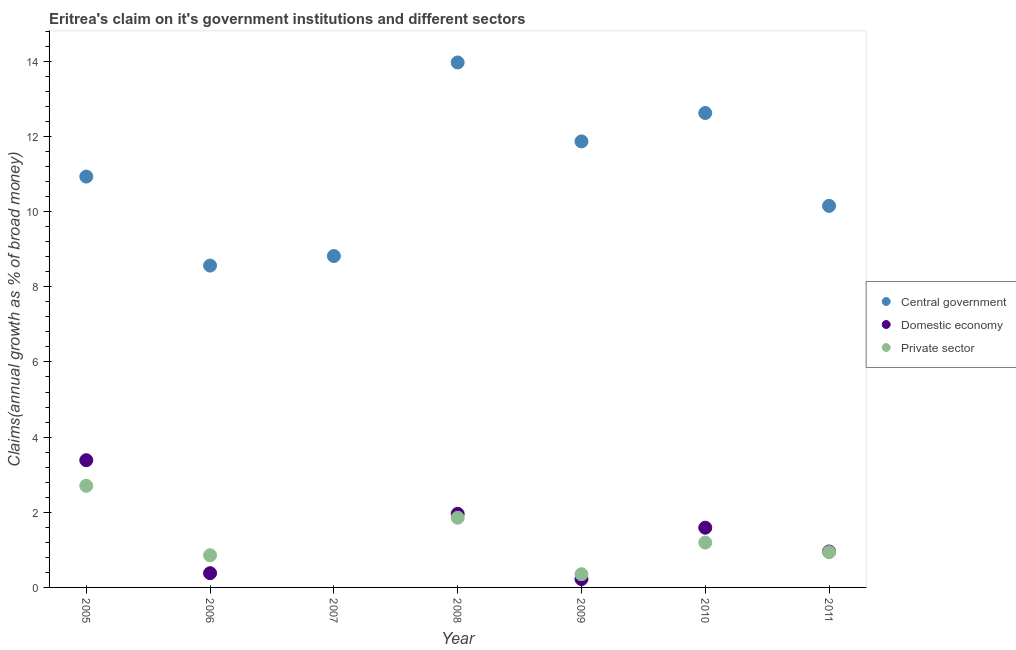What is the percentage of claim on the central government in 2007?
Keep it short and to the point. 8.82. Across all years, what is the maximum percentage of claim on the central government?
Your response must be concise. 13.97. Across all years, what is the minimum percentage of claim on the private sector?
Ensure brevity in your answer.  0. What is the total percentage of claim on the central government in the graph?
Ensure brevity in your answer.  76.93. What is the difference between the percentage of claim on the private sector in 2009 and that in 2011?
Ensure brevity in your answer.  -0.59. What is the difference between the percentage of claim on the private sector in 2008 and the percentage of claim on the central government in 2009?
Offer a terse response. -10.01. What is the average percentage of claim on the central government per year?
Give a very brief answer. 10.99. In the year 2006, what is the difference between the percentage of claim on the private sector and percentage of claim on the domestic economy?
Offer a terse response. 0.48. In how many years, is the percentage of claim on the domestic economy greater than 8 %?
Ensure brevity in your answer.  0. What is the ratio of the percentage of claim on the private sector in 2008 to that in 2011?
Ensure brevity in your answer.  1.98. Is the percentage of claim on the domestic economy in 2008 less than that in 2010?
Make the answer very short. No. Is the difference between the percentage of claim on the central government in 2006 and 2010 greater than the difference between the percentage of claim on the private sector in 2006 and 2010?
Keep it short and to the point. No. What is the difference between the highest and the second highest percentage of claim on the private sector?
Provide a succinct answer. 0.85. What is the difference between the highest and the lowest percentage of claim on the domestic economy?
Your response must be concise. 3.39. In how many years, is the percentage of claim on the domestic economy greater than the average percentage of claim on the domestic economy taken over all years?
Provide a short and direct response. 3. Is the sum of the percentage of claim on the domestic economy in 2008 and 2011 greater than the maximum percentage of claim on the central government across all years?
Provide a short and direct response. No. Does the percentage of claim on the central government monotonically increase over the years?
Your response must be concise. No. Is the percentage of claim on the private sector strictly greater than the percentage of claim on the central government over the years?
Make the answer very short. No. How many dotlines are there?
Ensure brevity in your answer.  3. Are the values on the major ticks of Y-axis written in scientific E-notation?
Your answer should be compact. No. Does the graph contain any zero values?
Your answer should be compact. Yes. Where does the legend appear in the graph?
Ensure brevity in your answer.  Center right. How are the legend labels stacked?
Provide a short and direct response. Vertical. What is the title of the graph?
Your answer should be very brief. Eritrea's claim on it's government institutions and different sectors. What is the label or title of the Y-axis?
Your response must be concise. Claims(annual growth as % of broad money). What is the Claims(annual growth as % of broad money) of Central government in 2005?
Your answer should be compact. 10.93. What is the Claims(annual growth as % of broad money) in Domestic economy in 2005?
Your answer should be compact. 3.39. What is the Claims(annual growth as % of broad money) of Private sector in 2005?
Your answer should be very brief. 2.7. What is the Claims(annual growth as % of broad money) of Central government in 2006?
Your answer should be compact. 8.56. What is the Claims(annual growth as % of broad money) in Domestic economy in 2006?
Your answer should be compact. 0.38. What is the Claims(annual growth as % of broad money) in Private sector in 2006?
Make the answer very short. 0.86. What is the Claims(annual growth as % of broad money) in Central government in 2007?
Provide a short and direct response. 8.82. What is the Claims(annual growth as % of broad money) of Central government in 2008?
Your response must be concise. 13.97. What is the Claims(annual growth as % of broad money) in Domestic economy in 2008?
Ensure brevity in your answer.  1.96. What is the Claims(annual growth as % of broad money) in Private sector in 2008?
Your answer should be compact. 1.85. What is the Claims(annual growth as % of broad money) of Central government in 2009?
Make the answer very short. 11.87. What is the Claims(annual growth as % of broad money) in Domestic economy in 2009?
Provide a succinct answer. 0.22. What is the Claims(annual growth as % of broad money) in Private sector in 2009?
Ensure brevity in your answer.  0.35. What is the Claims(annual growth as % of broad money) in Central government in 2010?
Keep it short and to the point. 12.62. What is the Claims(annual growth as % of broad money) in Domestic economy in 2010?
Make the answer very short. 1.59. What is the Claims(annual growth as % of broad money) of Private sector in 2010?
Provide a succinct answer. 1.19. What is the Claims(annual growth as % of broad money) of Central government in 2011?
Provide a succinct answer. 10.15. What is the Claims(annual growth as % of broad money) in Domestic economy in 2011?
Give a very brief answer. 0.96. What is the Claims(annual growth as % of broad money) in Private sector in 2011?
Provide a short and direct response. 0.94. Across all years, what is the maximum Claims(annual growth as % of broad money) in Central government?
Make the answer very short. 13.97. Across all years, what is the maximum Claims(annual growth as % of broad money) of Domestic economy?
Give a very brief answer. 3.39. Across all years, what is the maximum Claims(annual growth as % of broad money) of Private sector?
Offer a terse response. 2.7. Across all years, what is the minimum Claims(annual growth as % of broad money) in Central government?
Your response must be concise. 8.56. Across all years, what is the minimum Claims(annual growth as % of broad money) of Domestic economy?
Ensure brevity in your answer.  0. What is the total Claims(annual growth as % of broad money) of Central government in the graph?
Make the answer very short. 76.93. What is the total Claims(annual growth as % of broad money) in Domestic economy in the graph?
Provide a short and direct response. 8.49. What is the total Claims(annual growth as % of broad money) in Private sector in the graph?
Your answer should be compact. 7.9. What is the difference between the Claims(annual growth as % of broad money) of Central government in 2005 and that in 2006?
Give a very brief answer. 2.37. What is the difference between the Claims(annual growth as % of broad money) in Domestic economy in 2005 and that in 2006?
Give a very brief answer. 3.01. What is the difference between the Claims(annual growth as % of broad money) of Private sector in 2005 and that in 2006?
Offer a very short reply. 1.85. What is the difference between the Claims(annual growth as % of broad money) of Central government in 2005 and that in 2007?
Your answer should be compact. 2.11. What is the difference between the Claims(annual growth as % of broad money) of Central government in 2005 and that in 2008?
Your answer should be very brief. -3.04. What is the difference between the Claims(annual growth as % of broad money) in Domestic economy in 2005 and that in 2008?
Your answer should be compact. 1.43. What is the difference between the Claims(annual growth as % of broad money) in Private sector in 2005 and that in 2008?
Your response must be concise. 0.85. What is the difference between the Claims(annual growth as % of broad money) in Central government in 2005 and that in 2009?
Your answer should be compact. -0.94. What is the difference between the Claims(annual growth as % of broad money) of Domestic economy in 2005 and that in 2009?
Offer a terse response. 3.16. What is the difference between the Claims(annual growth as % of broad money) of Private sector in 2005 and that in 2009?
Make the answer very short. 2.35. What is the difference between the Claims(annual growth as % of broad money) of Central government in 2005 and that in 2010?
Your response must be concise. -1.69. What is the difference between the Claims(annual growth as % of broad money) in Domestic economy in 2005 and that in 2010?
Your answer should be compact. 1.8. What is the difference between the Claims(annual growth as % of broad money) of Private sector in 2005 and that in 2010?
Make the answer very short. 1.51. What is the difference between the Claims(annual growth as % of broad money) of Central government in 2005 and that in 2011?
Give a very brief answer. 0.78. What is the difference between the Claims(annual growth as % of broad money) in Domestic economy in 2005 and that in 2011?
Offer a terse response. 2.43. What is the difference between the Claims(annual growth as % of broad money) of Private sector in 2005 and that in 2011?
Provide a short and direct response. 1.77. What is the difference between the Claims(annual growth as % of broad money) in Central government in 2006 and that in 2007?
Your answer should be compact. -0.25. What is the difference between the Claims(annual growth as % of broad money) of Central government in 2006 and that in 2008?
Your answer should be compact. -5.41. What is the difference between the Claims(annual growth as % of broad money) of Domestic economy in 2006 and that in 2008?
Your answer should be very brief. -1.58. What is the difference between the Claims(annual growth as % of broad money) of Private sector in 2006 and that in 2008?
Provide a succinct answer. -1. What is the difference between the Claims(annual growth as % of broad money) in Central government in 2006 and that in 2009?
Provide a short and direct response. -3.3. What is the difference between the Claims(annual growth as % of broad money) in Domestic economy in 2006 and that in 2009?
Give a very brief answer. 0.16. What is the difference between the Claims(annual growth as % of broad money) of Private sector in 2006 and that in 2009?
Your response must be concise. 0.5. What is the difference between the Claims(annual growth as % of broad money) of Central government in 2006 and that in 2010?
Provide a succinct answer. -4.06. What is the difference between the Claims(annual growth as % of broad money) in Domestic economy in 2006 and that in 2010?
Your response must be concise. -1.21. What is the difference between the Claims(annual growth as % of broad money) in Private sector in 2006 and that in 2010?
Offer a very short reply. -0.34. What is the difference between the Claims(annual growth as % of broad money) in Central government in 2006 and that in 2011?
Make the answer very short. -1.59. What is the difference between the Claims(annual growth as % of broad money) in Domestic economy in 2006 and that in 2011?
Your answer should be compact. -0.58. What is the difference between the Claims(annual growth as % of broad money) of Private sector in 2006 and that in 2011?
Give a very brief answer. -0.08. What is the difference between the Claims(annual growth as % of broad money) of Central government in 2007 and that in 2008?
Your response must be concise. -5.15. What is the difference between the Claims(annual growth as % of broad money) in Central government in 2007 and that in 2009?
Provide a succinct answer. -3.05. What is the difference between the Claims(annual growth as % of broad money) in Central government in 2007 and that in 2010?
Make the answer very short. -3.81. What is the difference between the Claims(annual growth as % of broad money) in Central government in 2007 and that in 2011?
Give a very brief answer. -1.33. What is the difference between the Claims(annual growth as % of broad money) of Central government in 2008 and that in 2009?
Your answer should be very brief. 2.1. What is the difference between the Claims(annual growth as % of broad money) in Domestic economy in 2008 and that in 2009?
Your answer should be very brief. 1.74. What is the difference between the Claims(annual growth as % of broad money) of Private sector in 2008 and that in 2009?
Give a very brief answer. 1.5. What is the difference between the Claims(annual growth as % of broad money) of Central government in 2008 and that in 2010?
Give a very brief answer. 1.35. What is the difference between the Claims(annual growth as % of broad money) of Domestic economy in 2008 and that in 2010?
Make the answer very short. 0.37. What is the difference between the Claims(annual growth as % of broad money) of Private sector in 2008 and that in 2010?
Make the answer very short. 0.66. What is the difference between the Claims(annual growth as % of broad money) of Central government in 2008 and that in 2011?
Your answer should be very brief. 3.82. What is the difference between the Claims(annual growth as % of broad money) of Domestic economy in 2008 and that in 2011?
Ensure brevity in your answer.  1. What is the difference between the Claims(annual growth as % of broad money) in Private sector in 2008 and that in 2011?
Offer a very short reply. 0.92. What is the difference between the Claims(annual growth as % of broad money) of Central government in 2009 and that in 2010?
Your answer should be very brief. -0.76. What is the difference between the Claims(annual growth as % of broad money) of Domestic economy in 2009 and that in 2010?
Offer a very short reply. -1.37. What is the difference between the Claims(annual growth as % of broad money) of Private sector in 2009 and that in 2010?
Give a very brief answer. -0.84. What is the difference between the Claims(annual growth as % of broad money) in Central government in 2009 and that in 2011?
Keep it short and to the point. 1.72. What is the difference between the Claims(annual growth as % of broad money) in Domestic economy in 2009 and that in 2011?
Ensure brevity in your answer.  -0.73. What is the difference between the Claims(annual growth as % of broad money) in Private sector in 2009 and that in 2011?
Offer a very short reply. -0.59. What is the difference between the Claims(annual growth as % of broad money) in Central government in 2010 and that in 2011?
Your answer should be very brief. 2.47. What is the difference between the Claims(annual growth as % of broad money) of Domestic economy in 2010 and that in 2011?
Offer a terse response. 0.63. What is the difference between the Claims(annual growth as % of broad money) of Private sector in 2010 and that in 2011?
Keep it short and to the point. 0.26. What is the difference between the Claims(annual growth as % of broad money) in Central government in 2005 and the Claims(annual growth as % of broad money) in Domestic economy in 2006?
Offer a very short reply. 10.55. What is the difference between the Claims(annual growth as % of broad money) in Central government in 2005 and the Claims(annual growth as % of broad money) in Private sector in 2006?
Your response must be concise. 10.08. What is the difference between the Claims(annual growth as % of broad money) in Domestic economy in 2005 and the Claims(annual growth as % of broad money) in Private sector in 2006?
Keep it short and to the point. 2.53. What is the difference between the Claims(annual growth as % of broad money) of Central government in 2005 and the Claims(annual growth as % of broad money) of Domestic economy in 2008?
Provide a short and direct response. 8.97. What is the difference between the Claims(annual growth as % of broad money) in Central government in 2005 and the Claims(annual growth as % of broad money) in Private sector in 2008?
Make the answer very short. 9.08. What is the difference between the Claims(annual growth as % of broad money) of Domestic economy in 2005 and the Claims(annual growth as % of broad money) of Private sector in 2008?
Your answer should be very brief. 1.53. What is the difference between the Claims(annual growth as % of broad money) in Central government in 2005 and the Claims(annual growth as % of broad money) in Domestic economy in 2009?
Keep it short and to the point. 10.71. What is the difference between the Claims(annual growth as % of broad money) in Central government in 2005 and the Claims(annual growth as % of broad money) in Private sector in 2009?
Provide a succinct answer. 10.58. What is the difference between the Claims(annual growth as % of broad money) of Domestic economy in 2005 and the Claims(annual growth as % of broad money) of Private sector in 2009?
Provide a short and direct response. 3.03. What is the difference between the Claims(annual growth as % of broad money) in Central government in 2005 and the Claims(annual growth as % of broad money) in Domestic economy in 2010?
Make the answer very short. 9.34. What is the difference between the Claims(annual growth as % of broad money) in Central government in 2005 and the Claims(annual growth as % of broad money) in Private sector in 2010?
Give a very brief answer. 9.74. What is the difference between the Claims(annual growth as % of broad money) of Domestic economy in 2005 and the Claims(annual growth as % of broad money) of Private sector in 2010?
Offer a very short reply. 2.19. What is the difference between the Claims(annual growth as % of broad money) of Central government in 2005 and the Claims(annual growth as % of broad money) of Domestic economy in 2011?
Give a very brief answer. 9.98. What is the difference between the Claims(annual growth as % of broad money) of Central government in 2005 and the Claims(annual growth as % of broad money) of Private sector in 2011?
Offer a very short reply. 10. What is the difference between the Claims(annual growth as % of broad money) of Domestic economy in 2005 and the Claims(annual growth as % of broad money) of Private sector in 2011?
Ensure brevity in your answer.  2.45. What is the difference between the Claims(annual growth as % of broad money) of Central government in 2006 and the Claims(annual growth as % of broad money) of Domestic economy in 2008?
Keep it short and to the point. 6.61. What is the difference between the Claims(annual growth as % of broad money) in Central government in 2006 and the Claims(annual growth as % of broad money) in Private sector in 2008?
Offer a very short reply. 6.71. What is the difference between the Claims(annual growth as % of broad money) of Domestic economy in 2006 and the Claims(annual growth as % of broad money) of Private sector in 2008?
Make the answer very short. -1.47. What is the difference between the Claims(annual growth as % of broad money) in Central government in 2006 and the Claims(annual growth as % of broad money) in Domestic economy in 2009?
Your response must be concise. 8.34. What is the difference between the Claims(annual growth as % of broad money) in Central government in 2006 and the Claims(annual growth as % of broad money) in Private sector in 2009?
Give a very brief answer. 8.21. What is the difference between the Claims(annual growth as % of broad money) in Domestic economy in 2006 and the Claims(annual growth as % of broad money) in Private sector in 2009?
Make the answer very short. 0.03. What is the difference between the Claims(annual growth as % of broad money) of Central government in 2006 and the Claims(annual growth as % of broad money) of Domestic economy in 2010?
Your answer should be very brief. 6.98. What is the difference between the Claims(annual growth as % of broad money) in Central government in 2006 and the Claims(annual growth as % of broad money) in Private sector in 2010?
Keep it short and to the point. 7.37. What is the difference between the Claims(annual growth as % of broad money) in Domestic economy in 2006 and the Claims(annual growth as % of broad money) in Private sector in 2010?
Offer a very short reply. -0.81. What is the difference between the Claims(annual growth as % of broad money) of Central government in 2006 and the Claims(annual growth as % of broad money) of Domestic economy in 2011?
Offer a terse response. 7.61. What is the difference between the Claims(annual growth as % of broad money) in Central government in 2006 and the Claims(annual growth as % of broad money) in Private sector in 2011?
Keep it short and to the point. 7.63. What is the difference between the Claims(annual growth as % of broad money) of Domestic economy in 2006 and the Claims(annual growth as % of broad money) of Private sector in 2011?
Ensure brevity in your answer.  -0.56. What is the difference between the Claims(annual growth as % of broad money) in Central government in 2007 and the Claims(annual growth as % of broad money) in Domestic economy in 2008?
Provide a succinct answer. 6.86. What is the difference between the Claims(annual growth as % of broad money) in Central government in 2007 and the Claims(annual growth as % of broad money) in Private sector in 2008?
Your answer should be very brief. 6.97. What is the difference between the Claims(annual growth as % of broad money) in Central government in 2007 and the Claims(annual growth as % of broad money) in Domestic economy in 2009?
Give a very brief answer. 8.6. What is the difference between the Claims(annual growth as % of broad money) of Central government in 2007 and the Claims(annual growth as % of broad money) of Private sector in 2009?
Your answer should be very brief. 8.47. What is the difference between the Claims(annual growth as % of broad money) in Central government in 2007 and the Claims(annual growth as % of broad money) in Domestic economy in 2010?
Offer a very short reply. 7.23. What is the difference between the Claims(annual growth as % of broad money) in Central government in 2007 and the Claims(annual growth as % of broad money) in Private sector in 2010?
Your response must be concise. 7.63. What is the difference between the Claims(annual growth as % of broad money) in Central government in 2007 and the Claims(annual growth as % of broad money) in Domestic economy in 2011?
Ensure brevity in your answer.  7.86. What is the difference between the Claims(annual growth as % of broad money) of Central government in 2007 and the Claims(annual growth as % of broad money) of Private sector in 2011?
Your response must be concise. 7.88. What is the difference between the Claims(annual growth as % of broad money) of Central government in 2008 and the Claims(annual growth as % of broad money) of Domestic economy in 2009?
Make the answer very short. 13.75. What is the difference between the Claims(annual growth as % of broad money) in Central government in 2008 and the Claims(annual growth as % of broad money) in Private sector in 2009?
Ensure brevity in your answer.  13.62. What is the difference between the Claims(annual growth as % of broad money) of Domestic economy in 2008 and the Claims(annual growth as % of broad money) of Private sector in 2009?
Your answer should be compact. 1.61. What is the difference between the Claims(annual growth as % of broad money) in Central government in 2008 and the Claims(annual growth as % of broad money) in Domestic economy in 2010?
Keep it short and to the point. 12.38. What is the difference between the Claims(annual growth as % of broad money) of Central government in 2008 and the Claims(annual growth as % of broad money) of Private sector in 2010?
Your answer should be very brief. 12.78. What is the difference between the Claims(annual growth as % of broad money) of Domestic economy in 2008 and the Claims(annual growth as % of broad money) of Private sector in 2010?
Offer a terse response. 0.77. What is the difference between the Claims(annual growth as % of broad money) in Central government in 2008 and the Claims(annual growth as % of broad money) in Domestic economy in 2011?
Your response must be concise. 13.01. What is the difference between the Claims(annual growth as % of broad money) of Central government in 2008 and the Claims(annual growth as % of broad money) of Private sector in 2011?
Make the answer very short. 13.03. What is the difference between the Claims(annual growth as % of broad money) of Domestic economy in 2008 and the Claims(annual growth as % of broad money) of Private sector in 2011?
Keep it short and to the point. 1.02. What is the difference between the Claims(annual growth as % of broad money) in Central government in 2009 and the Claims(annual growth as % of broad money) in Domestic economy in 2010?
Keep it short and to the point. 10.28. What is the difference between the Claims(annual growth as % of broad money) in Central government in 2009 and the Claims(annual growth as % of broad money) in Private sector in 2010?
Provide a short and direct response. 10.68. What is the difference between the Claims(annual growth as % of broad money) of Domestic economy in 2009 and the Claims(annual growth as % of broad money) of Private sector in 2010?
Give a very brief answer. -0.97. What is the difference between the Claims(annual growth as % of broad money) of Central government in 2009 and the Claims(annual growth as % of broad money) of Domestic economy in 2011?
Your answer should be compact. 10.91. What is the difference between the Claims(annual growth as % of broad money) in Central government in 2009 and the Claims(annual growth as % of broad money) in Private sector in 2011?
Make the answer very short. 10.93. What is the difference between the Claims(annual growth as % of broad money) of Domestic economy in 2009 and the Claims(annual growth as % of broad money) of Private sector in 2011?
Provide a succinct answer. -0.71. What is the difference between the Claims(annual growth as % of broad money) in Central government in 2010 and the Claims(annual growth as % of broad money) in Domestic economy in 2011?
Provide a short and direct response. 11.67. What is the difference between the Claims(annual growth as % of broad money) in Central government in 2010 and the Claims(annual growth as % of broad money) in Private sector in 2011?
Offer a very short reply. 11.69. What is the difference between the Claims(annual growth as % of broad money) in Domestic economy in 2010 and the Claims(annual growth as % of broad money) in Private sector in 2011?
Keep it short and to the point. 0.65. What is the average Claims(annual growth as % of broad money) of Central government per year?
Provide a short and direct response. 10.99. What is the average Claims(annual growth as % of broad money) in Domestic economy per year?
Offer a very short reply. 1.21. What is the average Claims(annual growth as % of broad money) of Private sector per year?
Ensure brevity in your answer.  1.13. In the year 2005, what is the difference between the Claims(annual growth as % of broad money) in Central government and Claims(annual growth as % of broad money) in Domestic economy?
Make the answer very short. 7.55. In the year 2005, what is the difference between the Claims(annual growth as % of broad money) in Central government and Claims(annual growth as % of broad money) in Private sector?
Provide a short and direct response. 8.23. In the year 2005, what is the difference between the Claims(annual growth as % of broad money) of Domestic economy and Claims(annual growth as % of broad money) of Private sector?
Offer a very short reply. 0.68. In the year 2006, what is the difference between the Claims(annual growth as % of broad money) in Central government and Claims(annual growth as % of broad money) in Domestic economy?
Offer a very short reply. 8.19. In the year 2006, what is the difference between the Claims(annual growth as % of broad money) in Central government and Claims(annual growth as % of broad money) in Private sector?
Give a very brief answer. 7.71. In the year 2006, what is the difference between the Claims(annual growth as % of broad money) of Domestic economy and Claims(annual growth as % of broad money) of Private sector?
Give a very brief answer. -0.48. In the year 2008, what is the difference between the Claims(annual growth as % of broad money) of Central government and Claims(annual growth as % of broad money) of Domestic economy?
Offer a very short reply. 12.01. In the year 2008, what is the difference between the Claims(annual growth as % of broad money) of Central government and Claims(annual growth as % of broad money) of Private sector?
Offer a very short reply. 12.12. In the year 2008, what is the difference between the Claims(annual growth as % of broad money) in Domestic economy and Claims(annual growth as % of broad money) in Private sector?
Offer a terse response. 0.1. In the year 2009, what is the difference between the Claims(annual growth as % of broad money) in Central government and Claims(annual growth as % of broad money) in Domestic economy?
Offer a very short reply. 11.65. In the year 2009, what is the difference between the Claims(annual growth as % of broad money) of Central government and Claims(annual growth as % of broad money) of Private sector?
Your answer should be very brief. 11.52. In the year 2009, what is the difference between the Claims(annual growth as % of broad money) in Domestic economy and Claims(annual growth as % of broad money) in Private sector?
Give a very brief answer. -0.13. In the year 2010, what is the difference between the Claims(annual growth as % of broad money) in Central government and Claims(annual growth as % of broad money) in Domestic economy?
Your answer should be very brief. 11.04. In the year 2010, what is the difference between the Claims(annual growth as % of broad money) in Central government and Claims(annual growth as % of broad money) in Private sector?
Give a very brief answer. 11.43. In the year 2010, what is the difference between the Claims(annual growth as % of broad money) in Domestic economy and Claims(annual growth as % of broad money) in Private sector?
Make the answer very short. 0.4. In the year 2011, what is the difference between the Claims(annual growth as % of broad money) in Central government and Claims(annual growth as % of broad money) in Domestic economy?
Ensure brevity in your answer.  9.2. In the year 2011, what is the difference between the Claims(annual growth as % of broad money) in Central government and Claims(annual growth as % of broad money) in Private sector?
Ensure brevity in your answer.  9.22. In the year 2011, what is the difference between the Claims(annual growth as % of broad money) in Domestic economy and Claims(annual growth as % of broad money) in Private sector?
Your answer should be very brief. 0.02. What is the ratio of the Claims(annual growth as % of broad money) in Central government in 2005 to that in 2006?
Keep it short and to the point. 1.28. What is the ratio of the Claims(annual growth as % of broad money) of Domestic economy in 2005 to that in 2006?
Provide a short and direct response. 8.93. What is the ratio of the Claims(annual growth as % of broad money) of Private sector in 2005 to that in 2006?
Your answer should be compact. 3.16. What is the ratio of the Claims(annual growth as % of broad money) in Central government in 2005 to that in 2007?
Provide a short and direct response. 1.24. What is the ratio of the Claims(annual growth as % of broad money) of Central government in 2005 to that in 2008?
Offer a very short reply. 0.78. What is the ratio of the Claims(annual growth as % of broad money) in Domestic economy in 2005 to that in 2008?
Provide a short and direct response. 1.73. What is the ratio of the Claims(annual growth as % of broad money) of Private sector in 2005 to that in 2008?
Your answer should be very brief. 1.46. What is the ratio of the Claims(annual growth as % of broad money) of Central government in 2005 to that in 2009?
Give a very brief answer. 0.92. What is the ratio of the Claims(annual growth as % of broad money) in Domestic economy in 2005 to that in 2009?
Your answer should be very brief. 15.16. What is the ratio of the Claims(annual growth as % of broad money) of Private sector in 2005 to that in 2009?
Provide a succinct answer. 7.7. What is the ratio of the Claims(annual growth as % of broad money) in Central government in 2005 to that in 2010?
Your answer should be very brief. 0.87. What is the ratio of the Claims(annual growth as % of broad money) of Domestic economy in 2005 to that in 2010?
Provide a short and direct response. 2.13. What is the ratio of the Claims(annual growth as % of broad money) in Private sector in 2005 to that in 2010?
Keep it short and to the point. 2.27. What is the ratio of the Claims(annual growth as % of broad money) of Central government in 2005 to that in 2011?
Make the answer very short. 1.08. What is the ratio of the Claims(annual growth as % of broad money) of Domestic economy in 2005 to that in 2011?
Give a very brief answer. 3.54. What is the ratio of the Claims(annual growth as % of broad money) of Private sector in 2005 to that in 2011?
Make the answer very short. 2.88. What is the ratio of the Claims(annual growth as % of broad money) in Central government in 2006 to that in 2007?
Provide a succinct answer. 0.97. What is the ratio of the Claims(annual growth as % of broad money) of Central government in 2006 to that in 2008?
Offer a terse response. 0.61. What is the ratio of the Claims(annual growth as % of broad money) of Domestic economy in 2006 to that in 2008?
Ensure brevity in your answer.  0.19. What is the ratio of the Claims(annual growth as % of broad money) of Private sector in 2006 to that in 2008?
Give a very brief answer. 0.46. What is the ratio of the Claims(annual growth as % of broad money) of Central government in 2006 to that in 2009?
Your response must be concise. 0.72. What is the ratio of the Claims(annual growth as % of broad money) in Domestic economy in 2006 to that in 2009?
Offer a very short reply. 1.7. What is the ratio of the Claims(annual growth as % of broad money) in Private sector in 2006 to that in 2009?
Provide a short and direct response. 2.44. What is the ratio of the Claims(annual growth as % of broad money) in Central government in 2006 to that in 2010?
Your answer should be compact. 0.68. What is the ratio of the Claims(annual growth as % of broad money) of Domestic economy in 2006 to that in 2010?
Ensure brevity in your answer.  0.24. What is the ratio of the Claims(annual growth as % of broad money) of Private sector in 2006 to that in 2010?
Your answer should be very brief. 0.72. What is the ratio of the Claims(annual growth as % of broad money) in Central government in 2006 to that in 2011?
Offer a terse response. 0.84. What is the ratio of the Claims(annual growth as % of broad money) in Domestic economy in 2006 to that in 2011?
Your answer should be compact. 0.4. What is the ratio of the Claims(annual growth as % of broad money) in Private sector in 2006 to that in 2011?
Give a very brief answer. 0.91. What is the ratio of the Claims(annual growth as % of broad money) in Central government in 2007 to that in 2008?
Ensure brevity in your answer.  0.63. What is the ratio of the Claims(annual growth as % of broad money) in Central government in 2007 to that in 2009?
Your answer should be compact. 0.74. What is the ratio of the Claims(annual growth as % of broad money) of Central government in 2007 to that in 2010?
Give a very brief answer. 0.7. What is the ratio of the Claims(annual growth as % of broad money) in Central government in 2007 to that in 2011?
Your response must be concise. 0.87. What is the ratio of the Claims(annual growth as % of broad money) in Central government in 2008 to that in 2009?
Provide a succinct answer. 1.18. What is the ratio of the Claims(annual growth as % of broad money) of Domestic economy in 2008 to that in 2009?
Your answer should be compact. 8.77. What is the ratio of the Claims(annual growth as % of broad money) of Private sector in 2008 to that in 2009?
Your answer should be very brief. 5.28. What is the ratio of the Claims(annual growth as % of broad money) in Central government in 2008 to that in 2010?
Your answer should be compact. 1.11. What is the ratio of the Claims(annual growth as % of broad money) of Domestic economy in 2008 to that in 2010?
Your response must be concise. 1.23. What is the ratio of the Claims(annual growth as % of broad money) in Private sector in 2008 to that in 2010?
Offer a terse response. 1.55. What is the ratio of the Claims(annual growth as % of broad money) in Central government in 2008 to that in 2011?
Provide a short and direct response. 1.38. What is the ratio of the Claims(annual growth as % of broad money) in Domestic economy in 2008 to that in 2011?
Your response must be concise. 2.05. What is the ratio of the Claims(annual growth as % of broad money) of Private sector in 2008 to that in 2011?
Your response must be concise. 1.98. What is the ratio of the Claims(annual growth as % of broad money) in Central government in 2009 to that in 2010?
Offer a very short reply. 0.94. What is the ratio of the Claims(annual growth as % of broad money) in Domestic economy in 2009 to that in 2010?
Your response must be concise. 0.14. What is the ratio of the Claims(annual growth as % of broad money) in Private sector in 2009 to that in 2010?
Ensure brevity in your answer.  0.29. What is the ratio of the Claims(annual growth as % of broad money) of Central government in 2009 to that in 2011?
Offer a terse response. 1.17. What is the ratio of the Claims(annual growth as % of broad money) in Domestic economy in 2009 to that in 2011?
Your response must be concise. 0.23. What is the ratio of the Claims(annual growth as % of broad money) in Private sector in 2009 to that in 2011?
Your response must be concise. 0.37. What is the ratio of the Claims(annual growth as % of broad money) of Central government in 2010 to that in 2011?
Offer a terse response. 1.24. What is the ratio of the Claims(annual growth as % of broad money) in Domestic economy in 2010 to that in 2011?
Provide a short and direct response. 1.66. What is the ratio of the Claims(annual growth as % of broad money) of Private sector in 2010 to that in 2011?
Ensure brevity in your answer.  1.27. What is the difference between the highest and the second highest Claims(annual growth as % of broad money) in Central government?
Provide a short and direct response. 1.35. What is the difference between the highest and the second highest Claims(annual growth as % of broad money) in Domestic economy?
Your answer should be very brief. 1.43. What is the difference between the highest and the second highest Claims(annual growth as % of broad money) in Private sector?
Provide a succinct answer. 0.85. What is the difference between the highest and the lowest Claims(annual growth as % of broad money) in Central government?
Your answer should be very brief. 5.41. What is the difference between the highest and the lowest Claims(annual growth as % of broad money) of Domestic economy?
Provide a succinct answer. 3.39. What is the difference between the highest and the lowest Claims(annual growth as % of broad money) of Private sector?
Offer a very short reply. 2.7. 